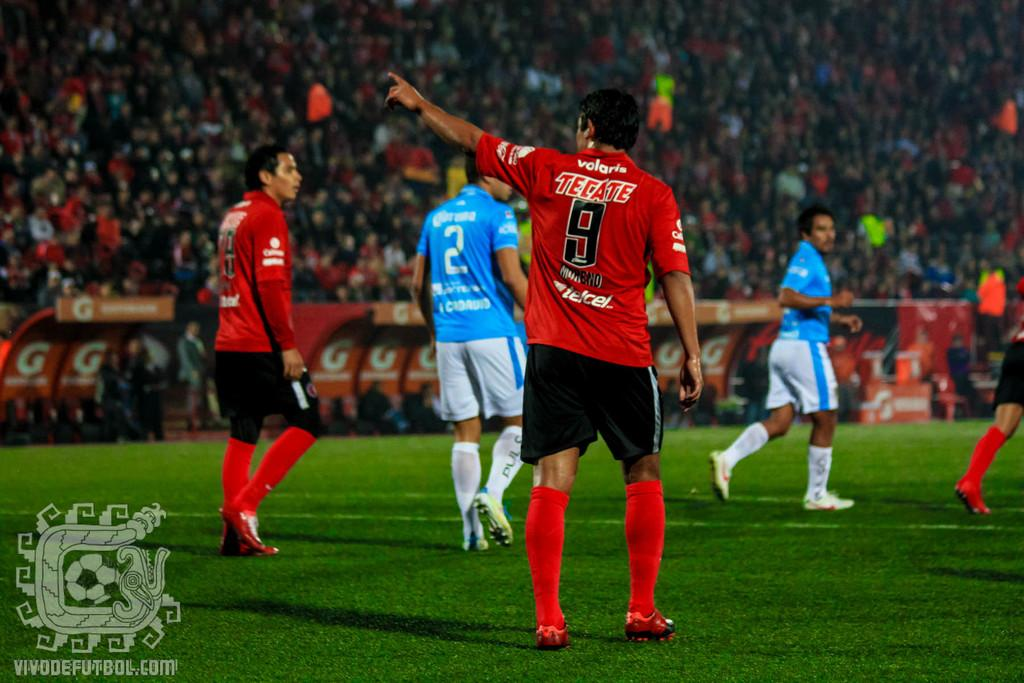What can be seen on the ground in the image? There are people visible on the ground in the image. What is located in the bottom left of the image? There is a symbol and text in the bottom left of the image. What is visible in the background of the image? There is a crowd in the background of the image. What type of produce is being sold by the people in the image? There is no produce visible in the image; it only shows people on the ground and a crowd in the background. What letters are being used to spell out a word in the image? There are no letters visible in the image; only a symbol and text are present in the bottom left corner. 